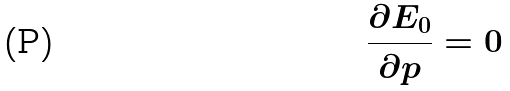<formula> <loc_0><loc_0><loc_500><loc_500>\frac { \partial E _ { 0 } } { \partial p } = 0</formula> 